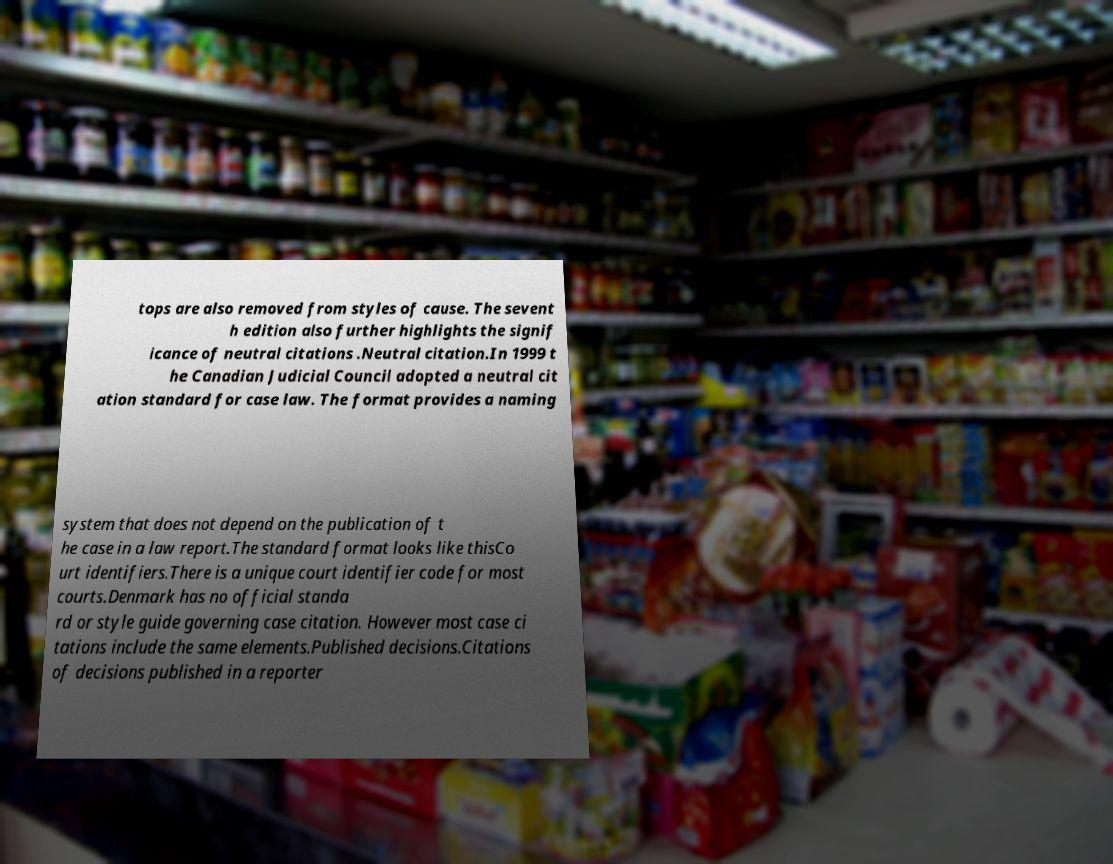Could you extract and type out the text from this image? tops are also removed from styles of cause. The sevent h edition also further highlights the signif icance of neutral citations .Neutral citation.In 1999 t he Canadian Judicial Council adopted a neutral cit ation standard for case law. The format provides a naming system that does not depend on the publication of t he case in a law report.The standard format looks like thisCo urt identifiers.There is a unique court identifier code for most courts.Denmark has no official standa rd or style guide governing case citation. However most case ci tations include the same elements.Published decisions.Citations of decisions published in a reporter 